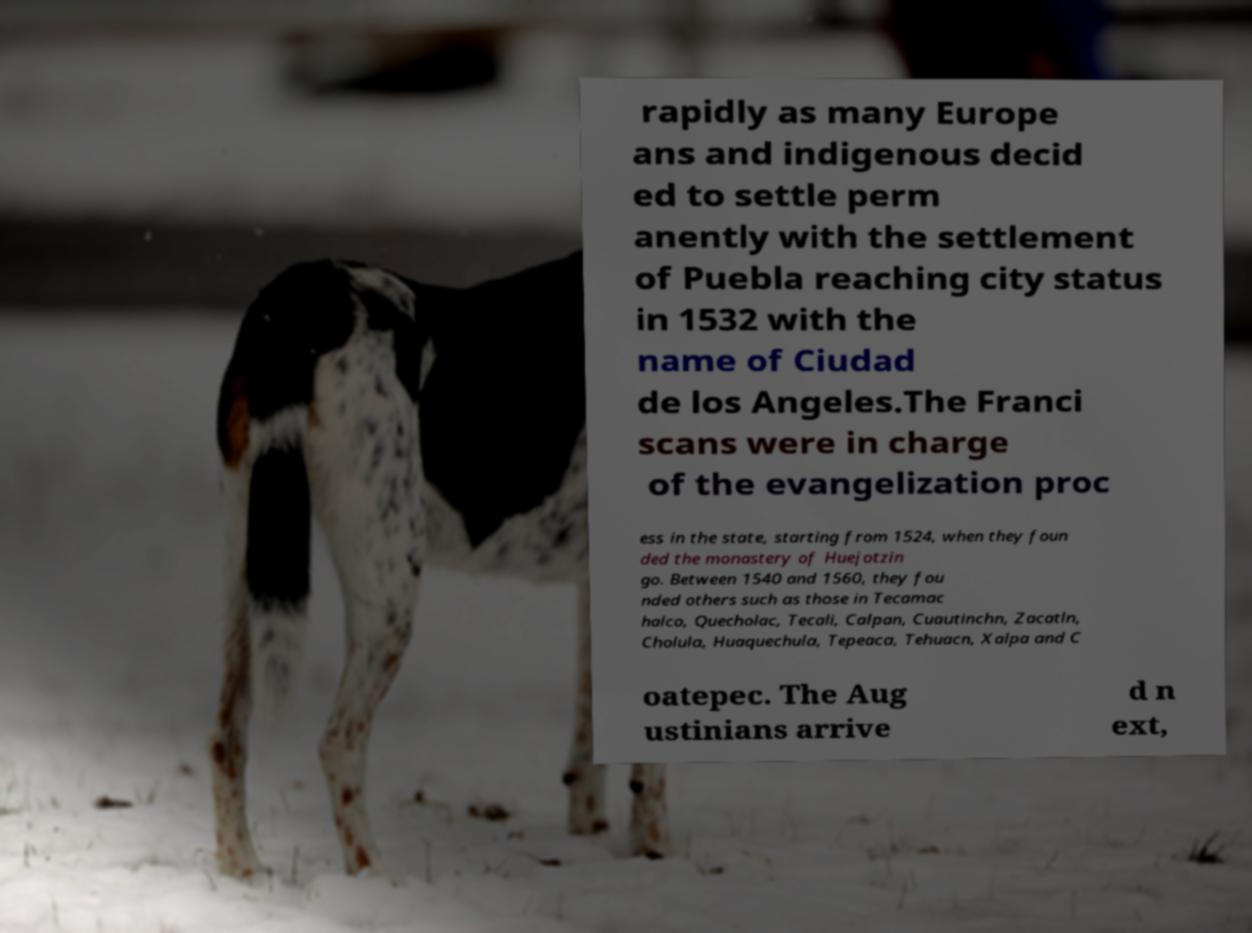Can you read and provide the text displayed in the image?This photo seems to have some interesting text. Can you extract and type it out for me? rapidly as many Europe ans and indigenous decid ed to settle perm anently with the settlement of Puebla reaching city status in 1532 with the name of Ciudad de los Angeles.The Franci scans were in charge of the evangelization proc ess in the state, starting from 1524, when they foun ded the monastery of Huejotzin go. Between 1540 and 1560, they fou nded others such as those in Tecamac halco, Quecholac, Tecali, Calpan, Cuautinchn, Zacatln, Cholula, Huaquechula, Tepeaca, Tehuacn, Xalpa and C oatepec. The Aug ustinians arrive d n ext, 